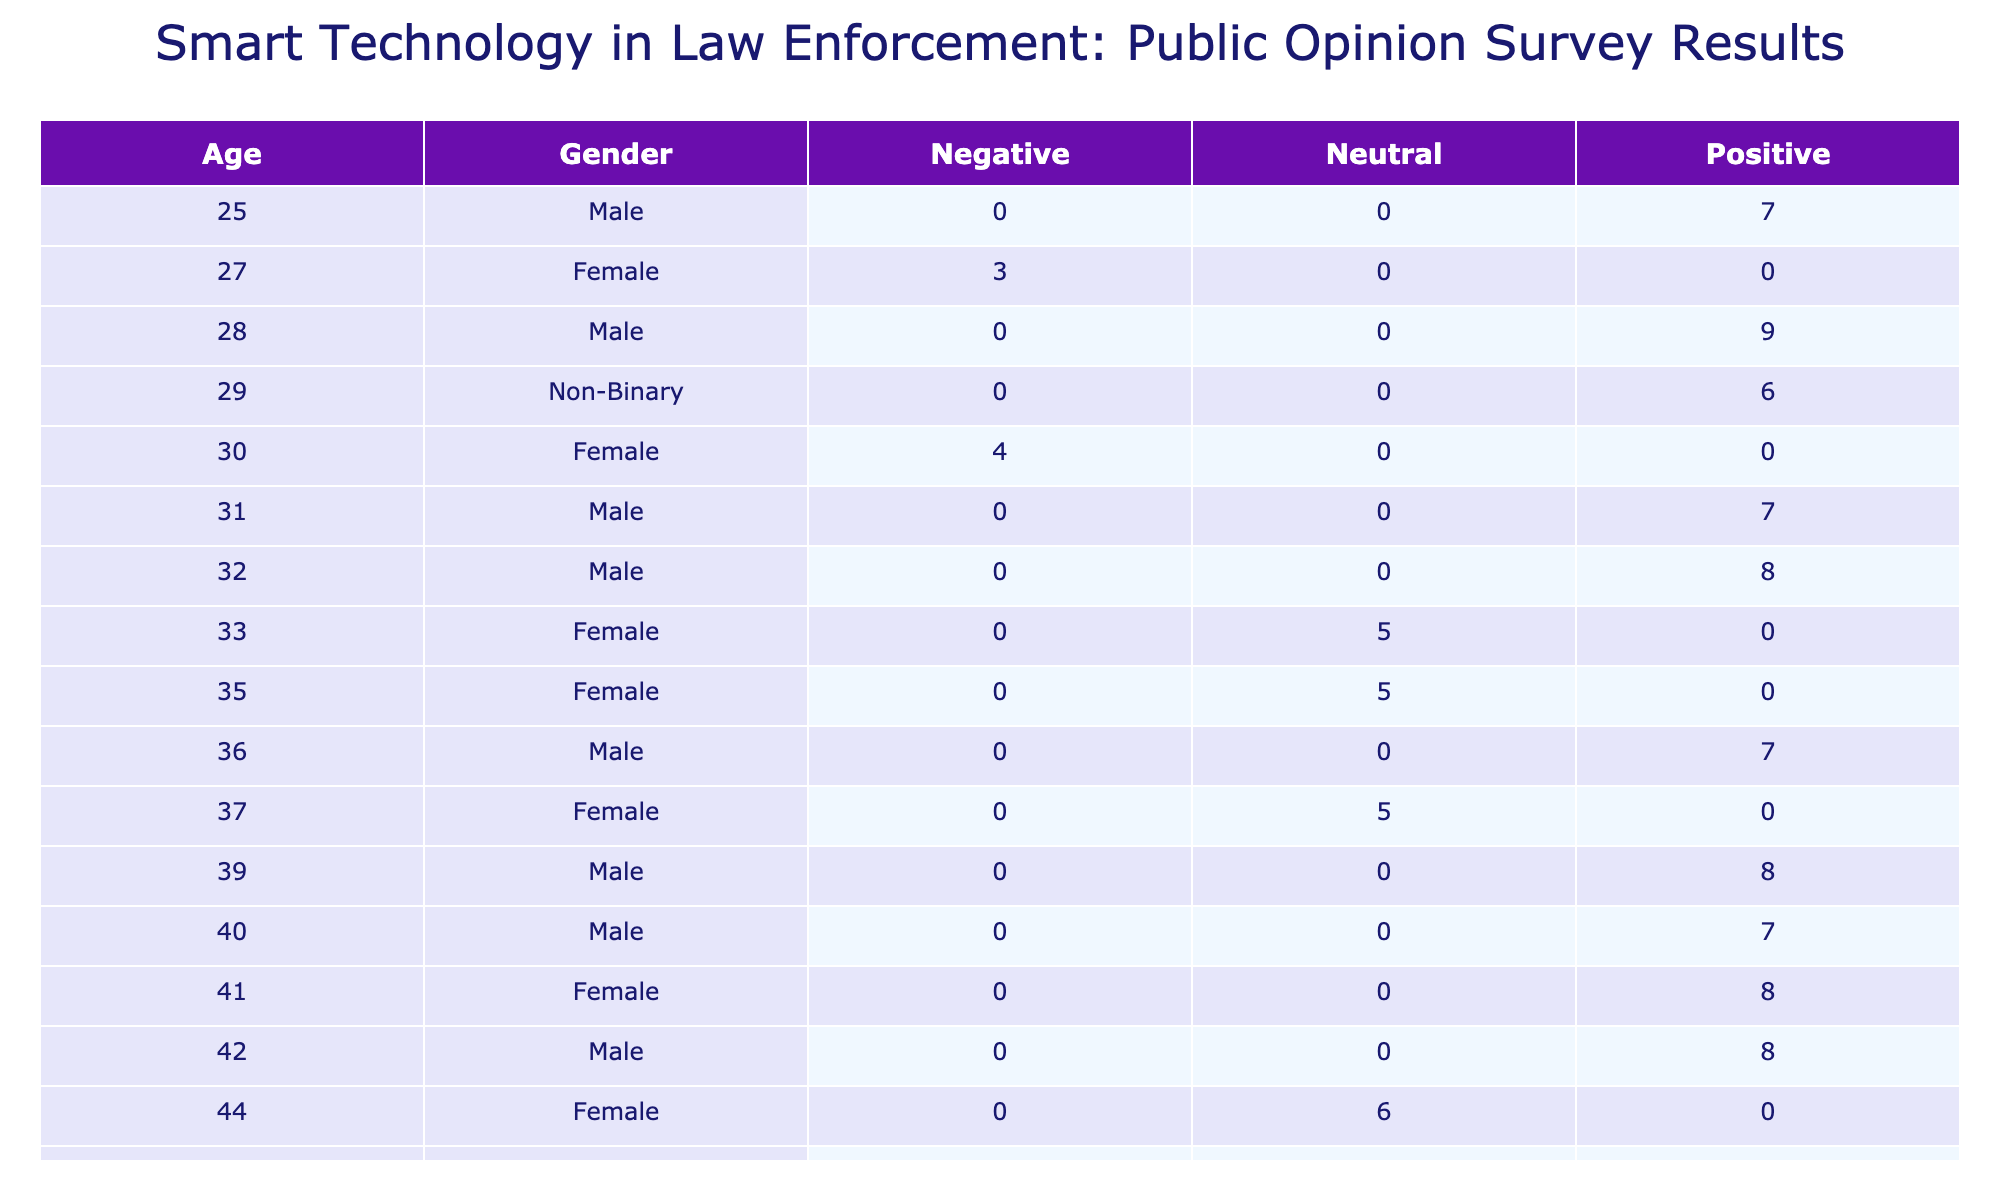What is the average support level for the 'Positive' opinion among males aged 30-50? To find the average support level for males aged 30-50 with a 'Positive' opinion, we first locate the relevant rows for this age range and gender. The ages that fall within this category are 30, 31, 33, 36, 39, and 40. The corresponding support levels are 7, 7, 7, 7, 8, and 7. Summing these values gives us 43, and since there are 6 data points, the average is 43/6 = 7.17.
Answer: 7.17 What support level do females aged 55 and above give to the 'Negative' opinion? There are two females aged 55 and above with a 'Negative' opinion: one aged 56 with a support level of 4 and one aged 63 with a support level of 2. The average is calculated as (4 + 2) / 2 = 3. Therefore, the average support level for females aged 55 and above for the 'Negative' opinion is 3.
Answer: 3 Is there any male under the age of 30 who supports the 'Neutral' opinion? We need to check if any males under 30 are listed with a 'Neutral' opinion in the table. However, upon reviewing the rows, no entry exists for male respondents under the age of 30 with a 'Neutral' opinion. Thus, the answer is no.
Answer: No How many respondents expressed a 'Negative' opinion and what is the sum of their support levels? We identify all respondents who have a 'Negative' opinion. From the table, we find that they are aged 52, 56, 63, 27, 50, and 30, with support levels being 3, 4, 2, 3, 4, and 4 respectively. Adding these levels yields a total of 3 + 4 + 2 + 3 + 4 + 4, which equals 20. Thus, the sum of support levels for those with a 'Negative' opinion is 20.
Answer: 20 What is the maximum support level for the 'Positive' opinion across different cities? To find the maximum support level for the 'Positive' opinion, we check each entry that has a 'Positive' opinion. The support levels found are 7, 8, 9, 8, 7, 7, 8, 9, and 7. The maximum support level among these is 9, which corresponds to respondents from San Diego and Seattle.
Answer: 9 